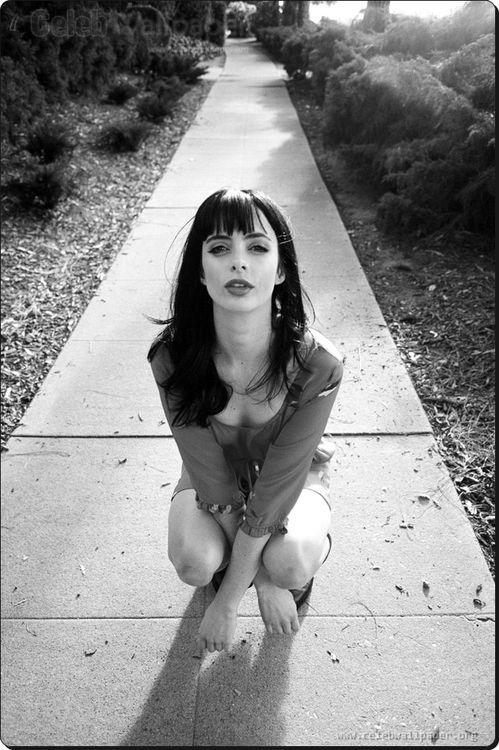How would you describe this image to someone who can't see it? This is a black and white photograph of a woman, actress Krysten Ritter, kneeling on a concrete sidewalk. She's wearing a light-colored blouse and dark pants. Her hair is styled with bangs that frame her face. Her expression is serious, and she is looking directly at the camera. The background includes a sidewalk stretching far back and some bushes lining the path. The overall scene feels introspective and thought-provoking.  Imagine you are Krysten's character. How do you feel in this moment? As Krysten's character in this moment, I feel a profound mix of determination and vulnerability. Kneeling on the sidewalk, a silent world around me, I am at a crossroads. My mind battles between memories of the past and decisions for the future. This moment is pivotal, a scene paused in time where I gather the strength to confront whatever lies ahead. 